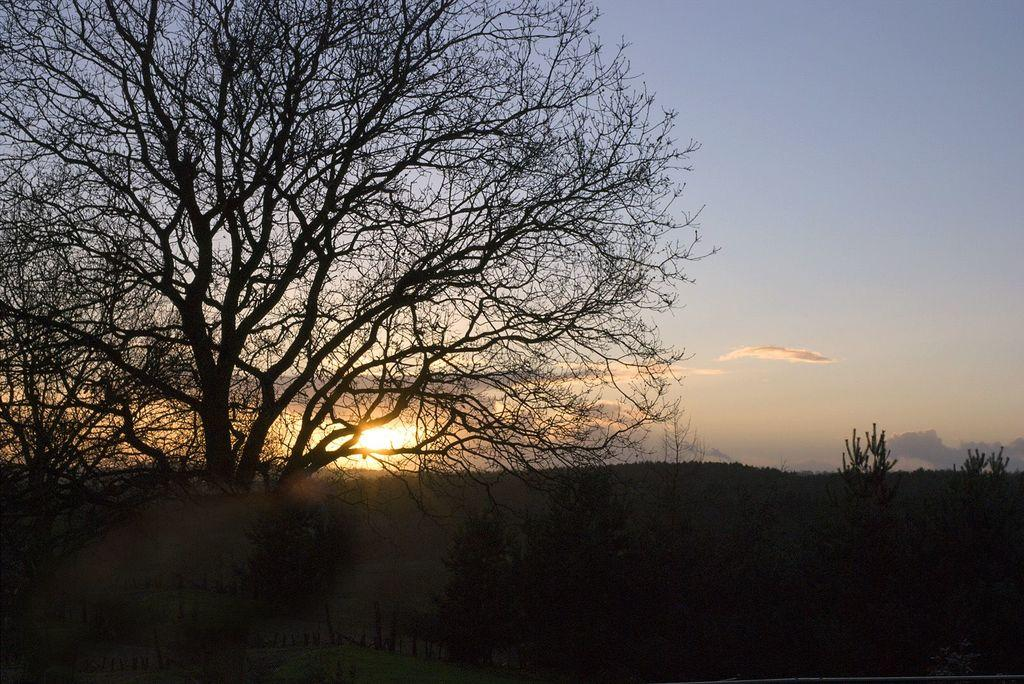What type of vegetation is in the foreground of the image? There are trees in the foreground of the image. How would you describe the lighting in the bottom part of the image? The bottom part of the image is dark. What can be seen in the background of the image? There is sky visible in the background of the image. Can the sun be seen in the sky? Yes, the sun is observable in the sky. What type of pie is being served in the afternoon in the image? There is no pie or reference to an afternoon in the image; it features trees in the foreground and a sky with the sun in the background. What game is being played in the image? There is no game being played in the image; it only shows trees, a dark bottom part, and the sky with the sun. 